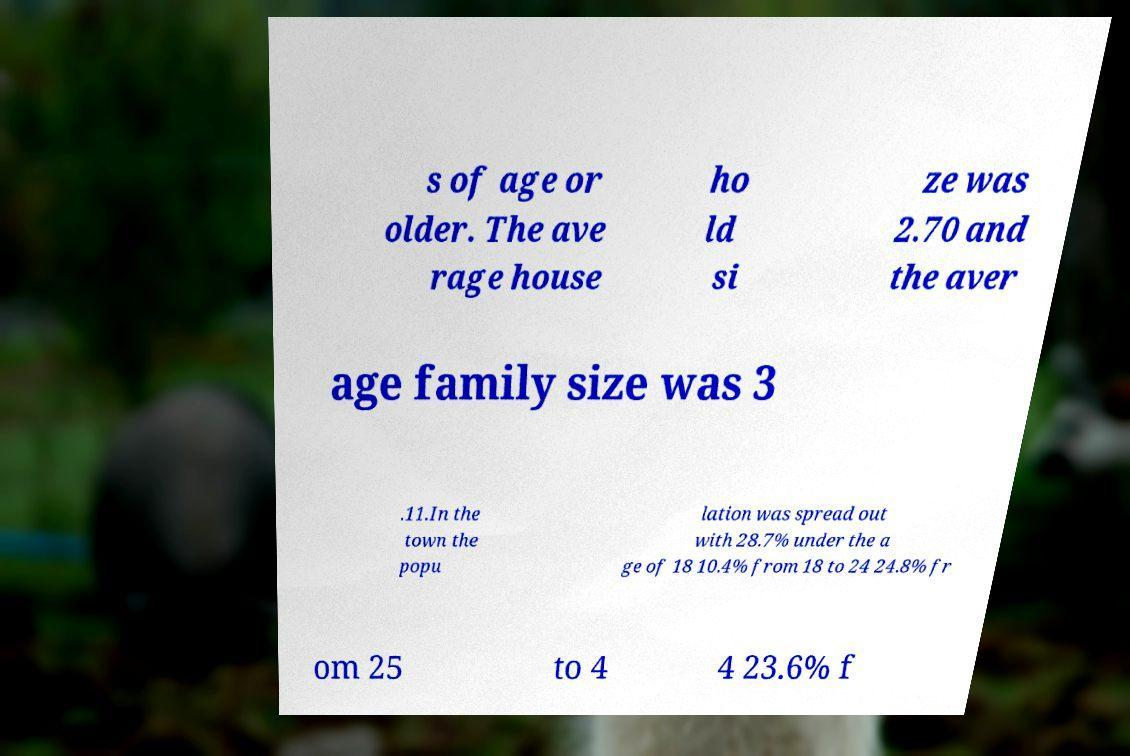Please read and relay the text visible in this image. What does it say? s of age or older. The ave rage house ho ld si ze was 2.70 and the aver age family size was 3 .11.In the town the popu lation was spread out with 28.7% under the a ge of 18 10.4% from 18 to 24 24.8% fr om 25 to 4 4 23.6% f 